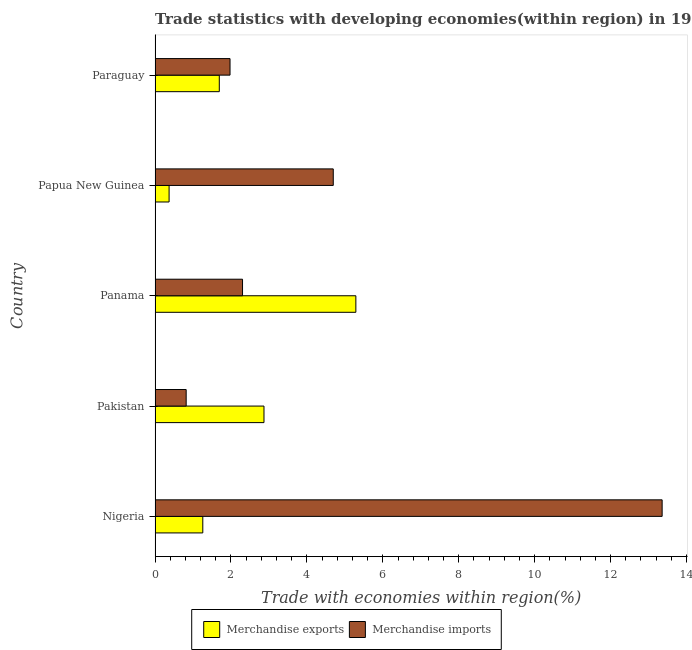How many bars are there on the 5th tick from the top?
Your response must be concise. 2. How many bars are there on the 5th tick from the bottom?
Your answer should be compact. 2. What is the label of the 5th group of bars from the top?
Offer a very short reply. Nigeria. In how many cases, is the number of bars for a given country not equal to the number of legend labels?
Provide a succinct answer. 0. What is the merchandise exports in Panama?
Your answer should be very brief. 5.29. Across all countries, what is the maximum merchandise exports?
Offer a very short reply. 5.29. Across all countries, what is the minimum merchandise imports?
Provide a succinct answer. 0.82. In which country was the merchandise exports maximum?
Keep it short and to the point. Panama. In which country was the merchandise imports minimum?
Provide a succinct answer. Pakistan. What is the total merchandise exports in the graph?
Your answer should be compact. 11.48. What is the difference between the merchandise imports in Pakistan and that in Papua New Guinea?
Your response must be concise. -3.88. What is the difference between the merchandise exports in Pakistan and the merchandise imports in Paraguay?
Your answer should be compact. 0.89. What is the average merchandise exports per country?
Give a very brief answer. 2.3. What is the difference between the merchandise imports and merchandise exports in Papua New Guinea?
Your answer should be very brief. 4.33. What is the ratio of the merchandise exports in Panama to that in Papua New Guinea?
Offer a terse response. 14.31. Is the difference between the merchandise imports in Pakistan and Paraguay greater than the difference between the merchandise exports in Pakistan and Paraguay?
Provide a short and direct response. No. What is the difference between the highest and the second highest merchandise imports?
Your response must be concise. 8.66. What is the difference between the highest and the lowest merchandise exports?
Provide a short and direct response. 4.92. In how many countries, is the merchandise exports greater than the average merchandise exports taken over all countries?
Give a very brief answer. 2. What does the 1st bar from the bottom in Pakistan represents?
Offer a very short reply. Merchandise exports. Are all the bars in the graph horizontal?
Offer a very short reply. Yes. How many countries are there in the graph?
Your response must be concise. 5. Does the graph contain any zero values?
Keep it short and to the point. No. Where does the legend appear in the graph?
Ensure brevity in your answer.  Bottom center. What is the title of the graph?
Offer a terse response. Trade statistics with developing economies(within region) in 1969. Does "Under-five" appear as one of the legend labels in the graph?
Give a very brief answer. No. What is the label or title of the X-axis?
Provide a succinct answer. Trade with economies within region(%). What is the Trade with economies within region(%) in Merchandise exports in Nigeria?
Give a very brief answer. 1.26. What is the Trade with economies within region(%) of Merchandise imports in Nigeria?
Ensure brevity in your answer.  13.36. What is the Trade with economies within region(%) of Merchandise exports in Pakistan?
Your answer should be very brief. 2.87. What is the Trade with economies within region(%) of Merchandise imports in Pakistan?
Keep it short and to the point. 0.82. What is the Trade with economies within region(%) in Merchandise exports in Panama?
Offer a very short reply. 5.29. What is the Trade with economies within region(%) of Merchandise imports in Panama?
Your response must be concise. 2.3. What is the Trade with economies within region(%) in Merchandise exports in Papua New Guinea?
Offer a very short reply. 0.37. What is the Trade with economies within region(%) in Merchandise imports in Papua New Guinea?
Offer a terse response. 4.69. What is the Trade with economies within region(%) in Merchandise exports in Paraguay?
Your response must be concise. 1.69. What is the Trade with economies within region(%) of Merchandise imports in Paraguay?
Ensure brevity in your answer.  1.97. Across all countries, what is the maximum Trade with economies within region(%) of Merchandise exports?
Your answer should be very brief. 5.29. Across all countries, what is the maximum Trade with economies within region(%) of Merchandise imports?
Your answer should be compact. 13.36. Across all countries, what is the minimum Trade with economies within region(%) of Merchandise exports?
Provide a succinct answer. 0.37. Across all countries, what is the minimum Trade with economies within region(%) of Merchandise imports?
Provide a succinct answer. 0.82. What is the total Trade with economies within region(%) of Merchandise exports in the graph?
Your answer should be very brief. 11.48. What is the total Trade with economies within region(%) of Merchandise imports in the graph?
Your answer should be compact. 23.15. What is the difference between the Trade with economies within region(%) in Merchandise exports in Nigeria and that in Pakistan?
Ensure brevity in your answer.  -1.61. What is the difference between the Trade with economies within region(%) of Merchandise imports in Nigeria and that in Pakistan?
Provide a short and direct response. 12.54. What is the difference between the Trade with economies within region(%) of Merchandise exports in Nigeria and that in Panama?
Keep it short and to the point. -4.03. What is the difference between the Trade with economies within region(%) of Merchandise imports in Nigeria and that in Panama?
Your answer should be compact. 11.05. What is the difference between the Trade with economies within region(%) in Merchandise exports in Nigeria and that in Papua New Guinea?
Offer a terse response. 0.89. What is the difference between the Trade with economies within region(%) in Merchandise imports in Nigeria and that in Papua New Guinea?
Your answer should be very brief. 8.66. What is the difference between the Trade with economies within region(%) in Merchandise exports in Nigeria and that in Paraguay?
Provide a short and direct response. -0.43. What is the difference between the Trade with economies within region(%) of Merchandise imports in Nigeria and that in Paraguay?
Offer a terse response. 11.38. What is the difference between the Trade with economies within region(%) in Merchandise exports in Pakistan and that in Panama?
Ensure brevity in your answer.  -2.42. What is the difference between the Trade with economies within region(%) of Merchandise imports in Pakistan and that in Panama?
Offer a terse response. -1.48. What is the difference between the Trade with economies within region(%) in Merchandise exports in Pakistan and that in Papua New Guinea?
Your response must be concise. 2.5. What is the difference between the Trade with economies within region(%) in Merchandise imports in Pakistan and that in Papua New Guinea?
Offer a very short reply. -3.87. What is the difference between the Trade with economies within region(%) of Merchandise exports in Pakistan and that in Paraguay?
Ensure brevity in your answer.  1.18. What is the difference between the Trade with economies within region(%) of Merchandise imports in Pakistan and that in Paraguay?
Your answer should be compact. -1.16. What is the difference between the Trade with economies within region(%) of Merchandise exports in Panama and that in Papua New Guinea?
Provide a short and direct response. 4.92. What is the difference between the Trade with economies within region(%) of Merchandise imports in Panama and that in Papua New Guinea?
Offer a terse response. -2.39. What is the difference between the Trade with economies within region(%) of Merchandise exports in Panama and that in Paraguay?
Provide a short and direct response. 3.6. What is the difference between the Trade with economies within region(%) in Merchandise imports in Panama and that in Paraguay?
Provide a succinct answer. 0.33. What is the difference between the Trade with economies within region(%) of Merchandise exports in Papua New Guinea and that in Paraguay?
Provide a short and direct response. -1.32. What is the difference between the Trade with economies within region(%) in Merchandise imports in Papua New Guinea and that in Paraguay?
Offer a very short reply. 2.72. What is the difference between the Trade with economies within region(%) in Merchandise exports in Nigeria and the Trade with economies within region(%) in Merchandise imports in Pakistan?
Your response must be concise. 0.44. What is the difference between the Trade with economies within region(%) of Merchandise exports in Nigeria and the Trade with economies within region(%) of Merchandise imports in Panama?
Provide a succinct answer. -1.05. What is the difference between the Trade with economies within region(%) in Merchandise exports in Nigeria and the Trade with economies within region(%) in Merchandise imports in Papua New Guinea?
Offer a terse response. -3.44. What is the difference between the Trade with economies within region(%) in Merchandise exports in Nigeria and the Trade with economies within region(%) in Merchandise imports in Paraguay?
Provide a short and direct response. -0.72. What is the difference between the Trade with economies within region(%) of Merchandise exports in Pakistan and the Trade with economies within region(%) of Merchandise imports in Panama?
Ensure brevity in your answer.  0.56. What is the difference between the Trade with economies within region(%) in Merchandise exports in Pakistan and the Trade with economies within region(%) in Merchandise imports in Papua New Guinea?
Your answer should be very brief. -1.83. What is the difference between the Trade with economies within region(%) of Merchandise exports in Pakistan and the Trade with economies within region(%) of Merchandise imports in Paraguay?
Your answer should be compact. 0.89. What is the difference between the Trade with economies within region(%) in Merchandise exports in Panama and the Trade with economies within region(%) in Merchandise imports in Papua New Guinea?
Ensure brevity in your answer.  0.6. What is the difference between the Trade with economies within region(%) of Merchandise exports in Panama and the Trade with economies within region(%) of Merchandise imports in Paraguay?
Your answer should be compact. 3.31. What is the difference between the Trade with economies within region(%) in Merchandise exports in Papua New Guinea and the Trade with economies within region(%) in Merchandise imports in Paraguay?
Make the answer very short. -1.61. What is the average Trade with economies within region(%) in Merchandise exports per country?
Make the answer very short. 2.3. What is the average Trade with economies within region(%) in Merchandise imports per country?
Provide a short and direct response. 4.63. What is the difference between the Trade with economies within region(%) of Merchandise exports and Trade with economies within region(%) of Merchandise imports in Nigeria?
Ensure brevity in your answer.  -12.1. What is the difference between the Trade with economies within region(%) of Merchandise exports and Trade with economies within region(%) of Merchandise imports in Pakistan?
Keep it short and to the point. 2.05. What is the difference between the Trade with economies within region(%) of Merchandise exports and Trade with economies within region(%) of Merchandise imports in Panama?
Your answer should be compact. 2.99. What is the difference between the Trade with economies within region(%) of Merchandise exports and Trade with economies within region(%) of Merchandise imports in Papua New Guinea?
Keep it short and to the point. -4.32. What is the difference between the Trade with economies within region(%) of Merchandise exports and Trade with economies within region(%) of Merchandise imports in Paraguay?
Provide a short and direct response. -0.28. What is the ratio of the Trade with economies within region(%) in Merchandise exports in Nigeria to that in Pakistan?
Offer a terse response. 0.44. What is the ratio of the Trade with economies within region(%) in Merchandise imports in Nigeria to that in Pakistan?
Your answer should be very brief. 16.3. What is the ratio of the Trade with economies within region(%) in Merchandise exports in Nigeria to that in Panama?
Keep it short and to the point. 0.24. What is the ratio of the Trade with economies within region(%) in Merchandise imports in Nigeria to that in Panama?
Your answer should be very brief. 5.8. What is the ratio of the Trade with economies within region(%) in Merchandise exports in Nigeria to that in Papua New Guinea?
Your answer should be very brief. 3.4. What is the ratio of the Trade with economies within region(%) of Merchandise imports in Nigeria to that in Papua New Guinea?
Your answer should be compact. 2.85. What is the ratio of the Trade with economies within region(%) of Merchandise exports in Nigeria to that in Paraguay?
Provide a short and direct response. 0.74. What is the ratio of the Trade with economies within region(%) of Merchandise imports in Nigeria to that in Paraguay?
Your answer should be compact. 6.76. What is the ratio of the Trade with economies within region(%) of Merchandise exports in Pakistan to that in Panama?
Keep it short and to the point. 0.54. What is the ratio of the Trade with economies within region(%) in Merchandise imports in Pakistan to that in Panama?
Your answer should be very brief. 0.36. What is the ratio of the Trade with economies within region(%) in Merchandise exports in Pakistan to that in Papua New Guinea?
Ensure brevity in your answer.  7.76. What is the ratio of the Trade with economies within region(%) of Merchandise imports in Pakistan to that in Papua New Guinea?
Your response must be concise. 0.17. What is the ratio of the Trade with economies within region(%) in Merchandise exports in Pakistan to that in Paraguay?
Make the answer very short. 1.7. What is the ratio of the Trade with economies within region(%) of Merchandise imports in Pakistan to that in Paraguay?
Offer a very short reply. 0.41. What is the ratio of the Trade with economies within region(%) of Merchandise exports in Panama to that in Papua New Guinea?
Offer a terse response. 14.31. What is the ratio of the Trade with economies within region(%) of Merchandise imports in Panama to that in Papua New Guinea?
Keep it short and to the point. 0.49. What is the ratio of the Trade with economies within region(%) in Merchandise exports in Panama to that in Paraguay?
Make the answer very short. 3.13. What is the ratio of the Trade with economies within region(%) in Merchandise imports in Panama to that in Paraguay?
Give a very brief answer. 1.17. What is the ratio of the Trade with economies within region(%) of Merchandise exports in Papua New Guinea to that in Paraguay?
Make the answer very short. 0.22. What is the ratio of the Trade with economies within region(%) of Merchandise imports in Papua New Guinea to that in Paraguay?
Give a very brief answer. 2.38. What is the difference between the highest and the second highest Trade with economies within region(%) in Merchandise exports?
Your answer should be compact. 2.42. What is the difference between the highest and the second highest Trade with economies within region(%) of Merchandise imports?
Give a very brief answer. 8.66. What is the difference between the highest and the lowest Trade with economies within region(%) of Merchandise exports?
Make the answer very short. 4.92. What is the difference between the highest and the lowest Trade with economies within region(%) of Merchandise imports?
Your answer should be very brief. 12.54. 